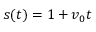<formula> <loc_0><loc_0><loc_500><loc_500>s ( t ) = 1 + v _ { 0 } t</formula> 